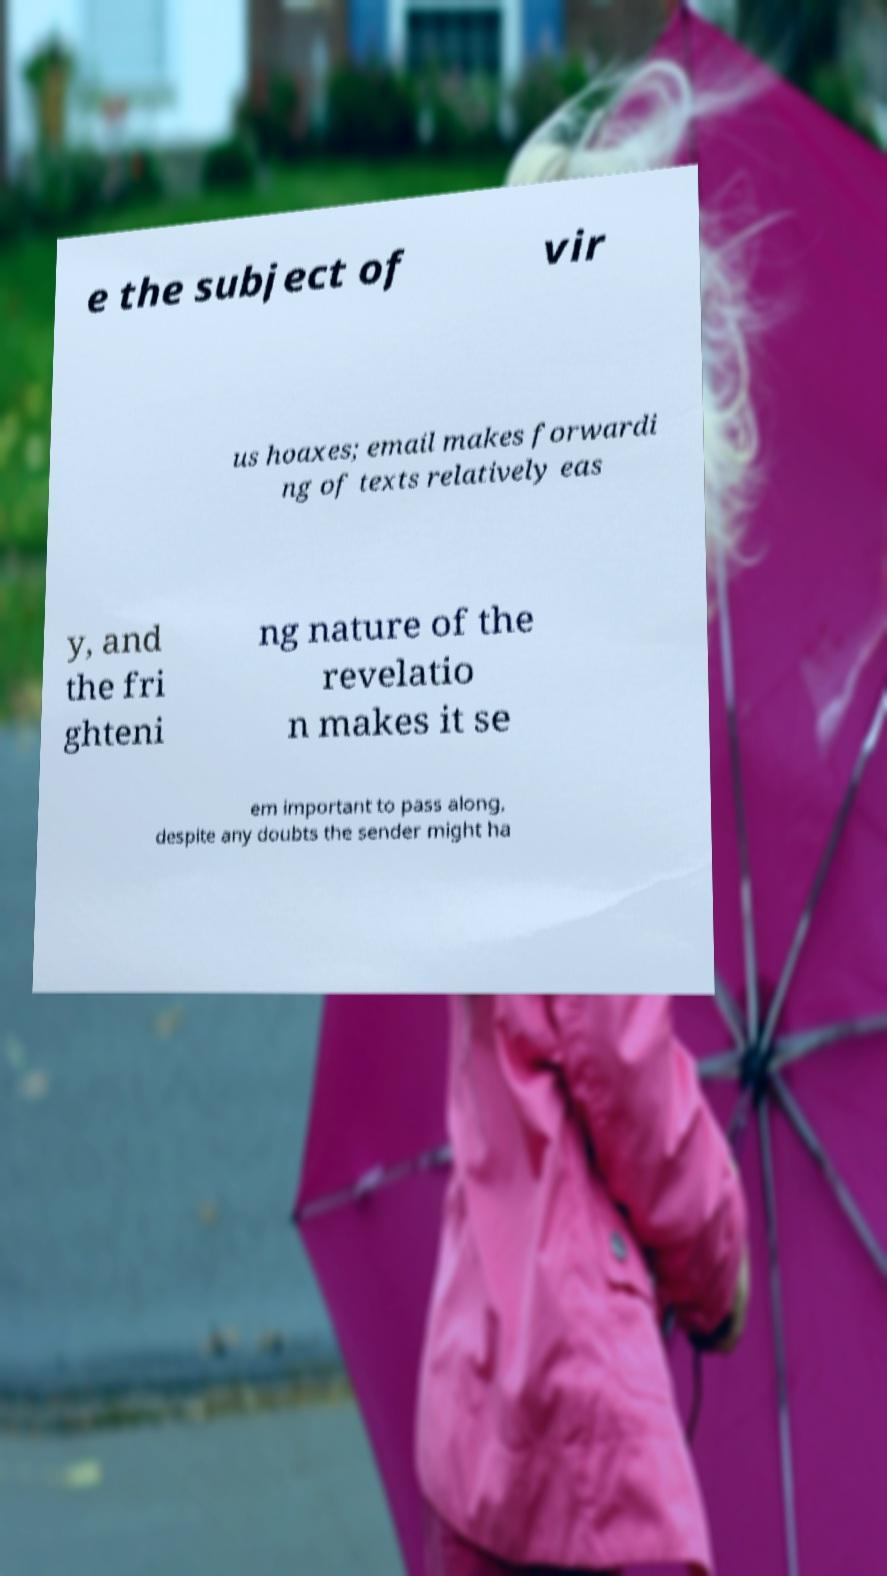Please read and relay the text visible in this image. What does it say? e the subject of vir us hoaxes; email makes forwardi ng of texts relatively eas y, and the fri ghteni ng nature of the revelatio n makes it se em important to pass along, despite any doubts the sender might ha 